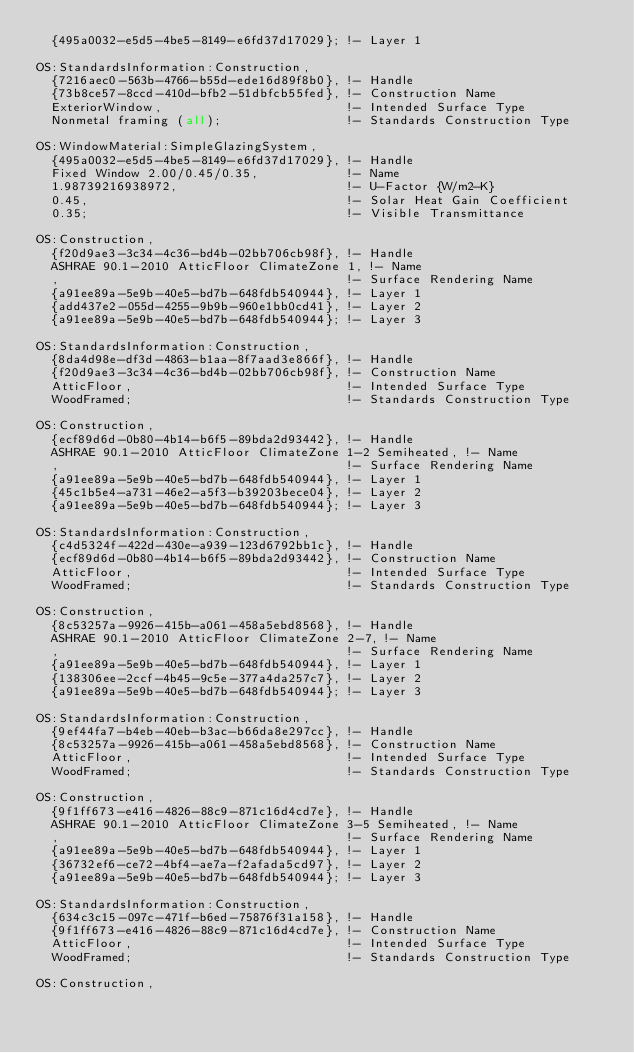Convert code to text. <code><loc_0><loc_0><loc_500><loc_500><_XML_>  {495a0032-e5d5-4be5-8149-e6fd37d17029}; !- Layer 1

OS:StandardsInformation:Construction,
  {7216aec0-563b-4766-b55d-ede16d89f8b0}, !- Handle
  {73b8ce57-8ccd-410d-bfb2-51dbfcb55fed}, !- Construction Name
  ExteriorWindow,                         !- Intended Surface Type
  Nonmetal framing (all);                 !- Standards Construction Type

OS:WindowMaterial:SimpleGlazingSystem,
  {495a0032-e5d5-4be5-8149-e6fd37d17029}, !- Handle
  Fixed Window 2.00/0.45/0.35,            !- Name
  1.98739216938972,                       !- U-Factor {W/m2-K}
  0.45,                                   !- Solar Heat Gain Coefficient
  0.35;                                   !- Visible Transmittance

OS:Construction,
  {f20d9ae3-3c34-4c36-bd4b-02bb706cb98f}, !- Handle
  ASHRAE 90.1-2010 AtticFloor ClimateZone 1, !- Name
  ,                                       !- Surface Rendering Name
  {a91ee89a-5e9b-40e5-bd7b-648fdb540944}, !- Layer 1
  {add437e2-055d-4255-9b9b-960e1bb0cd41}, !- Layer 2
  {a91ee89a-5e9b-40e5-bd7b-648fdb540944}; !- Layer 3

OS:StandardsInformation:Construction,
  {8da4d98e-df3d-4863-b1aa-8f7aad3e866f}, !- Handle
  {f20d9ae3-3c34-4c36-bd4b-02bb706cb98f}, !- Construction Name
  AtticFloor,                             !- Intended Surface Type
  WoodFramed;                             !- Standards Construction Type

OS:Construction,
  {ecf89d6d-0b80-4b14-b6f5-89bda2d93442}, !- Handle
  ASHRAE 90.1-2010 AtticFloor ClimateZone 1-2 Semiheated, !- Name
  ,                                       !- Surface Rendering Name
  {a91ee89a-5e9b-40e5-bd7b-648fdb540944}, !- Layer 1
  {45c1b5e4-a731-46e2-a5f3-b39203bece04}, !- Layer 2
  {a91ee89a-5e9b-40e5-bd7b-648fdb540944}; !- Layer 3

OS:StandardsInformation:Construction,
  {c4d5324f-422d-430e-a939-123d6792bb1c}, !- Handle
  {ecf89d6d-0b80-4b14-b6f5-89bda2d93442}, !- Construction Name
  AtticFloor,                             !- Intended Surface Type
  WoodFramed;                             !- Standards Construction Type

OS:Construction,
  {8c53257a-9926-415b-a061-458a5ebd8568}, !- Handle
  ASHRAE 90.1-2010 AtticFloor ClimateZone 2-7, !- Name
  ,                                       !- Surface Rendering Name
  {a91ee89a-5e9b-40e5-bd7b-648fdb540944}, !- Layer 1
  {138306ee-2ccf-4b45-9c5e-377a4da257c7}, !- Layer 2
  {a91ee89a-5e9b-40e5-bd7b-648fdb540944}; !- Layer 3

OS:StandardsInformation:Construction,
  {9ef44fa7-b4eb-40eb-b3ac-b66da8e297cc}, !- Handle
  {8c53257a-9926-415b-a061-458a5ebd8568}, !- Construction Name
  AtticFloor,                             !- Intended Surface Type
  WoodFramed;                             !- Standards Construction Type

OS:Construction,
  {9f1ff673-e416-4826-88c9-871c16d4cd7e}, !- Handle
  ASHRAE 90.1-2010 AtticFloor ClimateZone 3-5 Semiheated, !- Name
  ,                                       !- Surface Rendering Name
  {a91ee89a-5e9b-40e5-bd7b-648fdb540944}, !- Layer 1
  {36732ef6-ce72-4bf4-ae7a-f2afada5cd97}, !- Layer 2
  {a91ee89a-5e9b-40e5-bd7b-648fdb540944}; !- Layer 3

OS:StandardsInformation:Construction,
  {634c3c15-097c-471f-b6ed-75876f31a158}, !- Handle
  {9f1ff673-e416-4826-88c9-871c16d4cd7e}, !- Construction Name
  AtticFloor,                             !- Intended Surface Type
  WoodFramed;                             !- Standards Construction Type

OS:Construction,</code> 